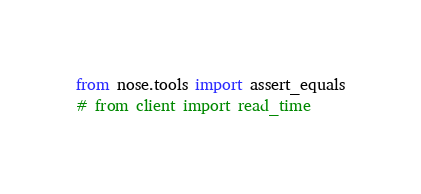Convert code to text. <code><loc_0><loc_0><loc_500><loc_500><_Python_>from nose.tools import assert_equals
# from client import read_time</code> 